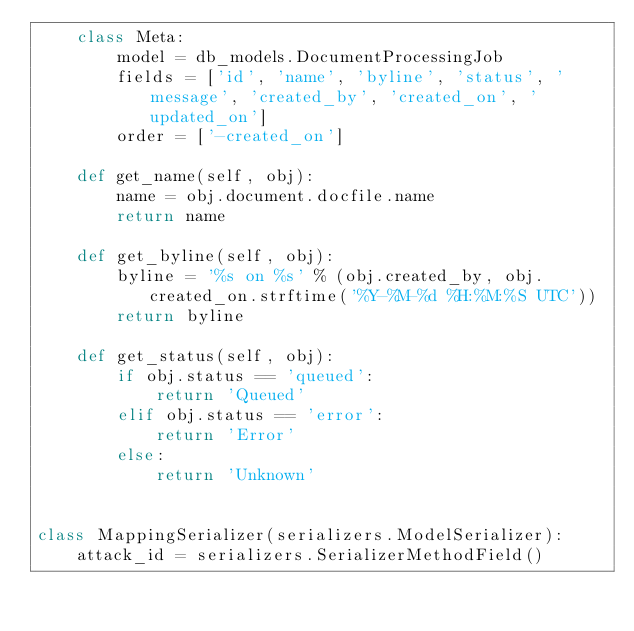<code> <loc_0><loc_0><loc_500><loc_500><_Python_>    class Meta:
        model = db_models.DocumentProcessingJob
        fields = ['id', 'name', 'byline', 'status', 'message', 'created_by', 'created_on', 'updated_on']
        order = ['-created_on']

    def get_name(self, obj):
        name = obj.document.docfile.name
        return name

    def get_byline(self, obj):
        byline = '%s on %s' % (obj.created_by, obj.created_on.strftime('%Y-%M-%d %H:%M:%S UTC'))
        return byline

    def get_status(self, obj):
        if obj.status == 'queued':
            return 'Queued'
        elif obj.status == 'error':
            return 'Error'
        else:
            return 'Unknown'


class MappingSerializer(serializers.ModelSerializer):
    attack_id = serializers.SerializerMethodField()</code> 